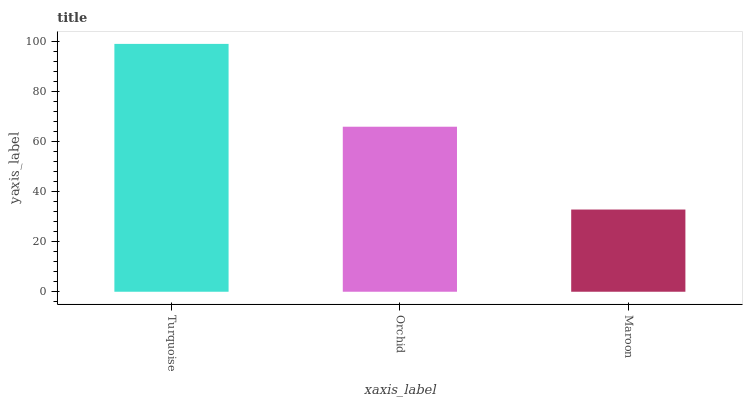Is Maroon the minimum?
Answer yes or no. Yes. Is Turquoise the maximum?
Answer yes or no. Yes. Is Orchid the minimum?
Answer yes or no. No. Is Orchid the maximum?
Answer yes or no. No. Is Turquoise greater than Orchid?
Answer yes or no. Yes. Is Orchid less than Turquoise?
Answer yes or no. Yes. Is Orchid greater than Turquoise?
Answer yes or no. No. Is Turquoise less than Orchid?
Answer yes or no. No. Is Orchid the high median?
Answer yes or no. Yes. Is Orchid the low median?
Answer yes or no. Yes. Is Maroon the high median?
Answer yes or no. No. Is Turquoise the low median?
Answer yes or no. No. 